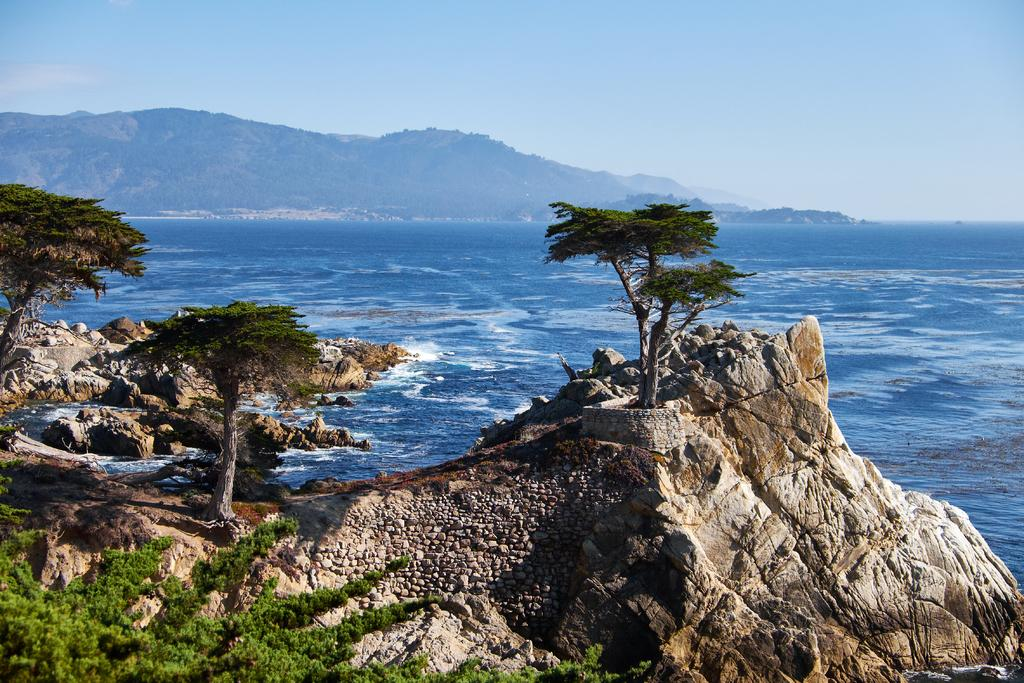What type of natural elements can be seen in the image? There are trees, rocks, and water visible in the image. What can be seen in the distance in the image? In the background of the image, there are hills. What is visible in the sky in the image? Clouds are present in the background of the image. What type of quill is being used to write on the rocks in the image? There is no quill or writing present in the image; it features natural elements such as trees, rocks, water, hills, and clouds. 